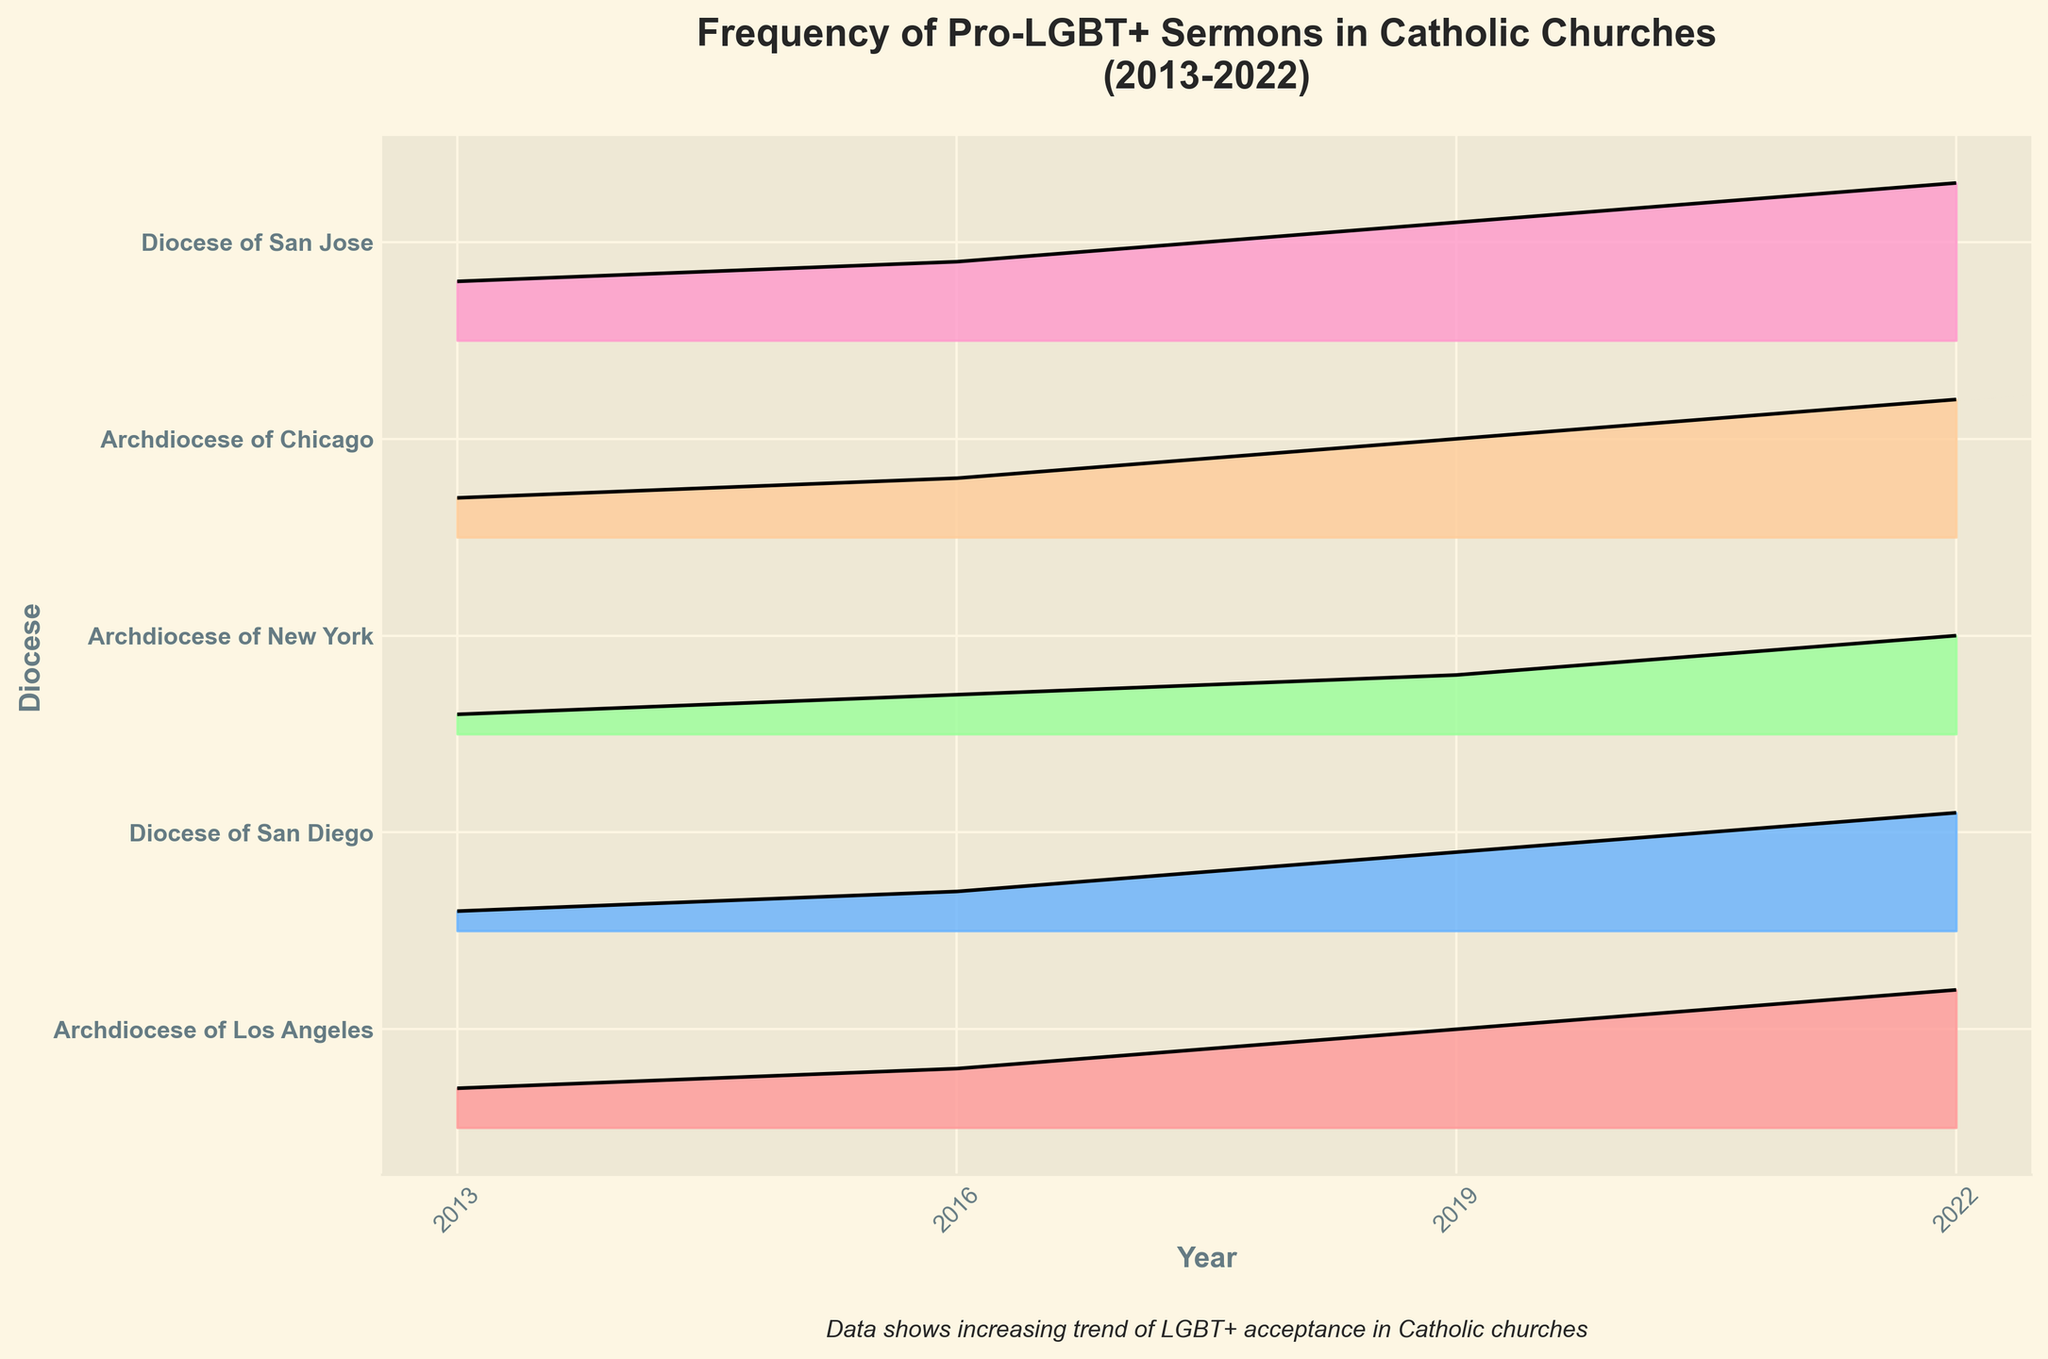What is the title of the figure? The title is typically located at the top of the figure. In this case, it says "Frequency of Pro-LGBT+ Sermons in Catholic Churches (2013-2022)"
Answer: Frequency of Pro-LGBT+ Sermons in Catholic Churches (2013-2022) Which diocese had the highest frequency of pro-LGBT+ sermons in 2022? To determine this, look at the heights of the filled curves in 2022. The Diocese of San Jose has the highest peak in the 2022 plot.
Answer: Diocese of San Jose What colors are used for the different dioceses? The fill colors of the curves represent different dioceses. They include shades of pink, blue, green, tan, and pink.
Answer: Shades of pink, blue, green, tan, and pink How many continents are represented? The y-axis labels indicate different dioceses, and there are a total of five: "Archdiocese of Los Angeles," "Diocese of San Diego," "Archdiocese of New York," "Archdiocese of Chicago," and "Diocese of San Jose." Each unique label counts as one.
Answer: Five What is the trend in the frequency of pro-LGBT+ sermons from 2013 to 2022? Look at the overall direction of the filled curves from 2013 to 2022, which show a general upward trend indicating an increase in pro-LGBT+ sermons over the years.
Answer: Increasing Which diocese shows the most substantial increase in frequency over the decade? Consider the change in height from 2013 to 2022 for each diocese. The Diocese of San Jose shows the most substantial increase, from 0.3 in 2013 to 0.8 in 2022.
Answer: Diocese of San Jose In what year did the Archdiocese of New York and the Archdiocese of Chicago have an equal frequency of sermons? Look for the specific years where the heights of the filled curves for both dioceses are the same. In 2013, both have a frequency of 0.1.
Answer: 2013 What does the note at the bottom of the figure suggest? There is a text note at the bottom of the figure which states, "Data shows increasing trend of LGBT+ acceptance in Catholic churches." This is an observation conclusion.
Answer: Increasing trend of LGBT+ acceptance in Catholic churches 